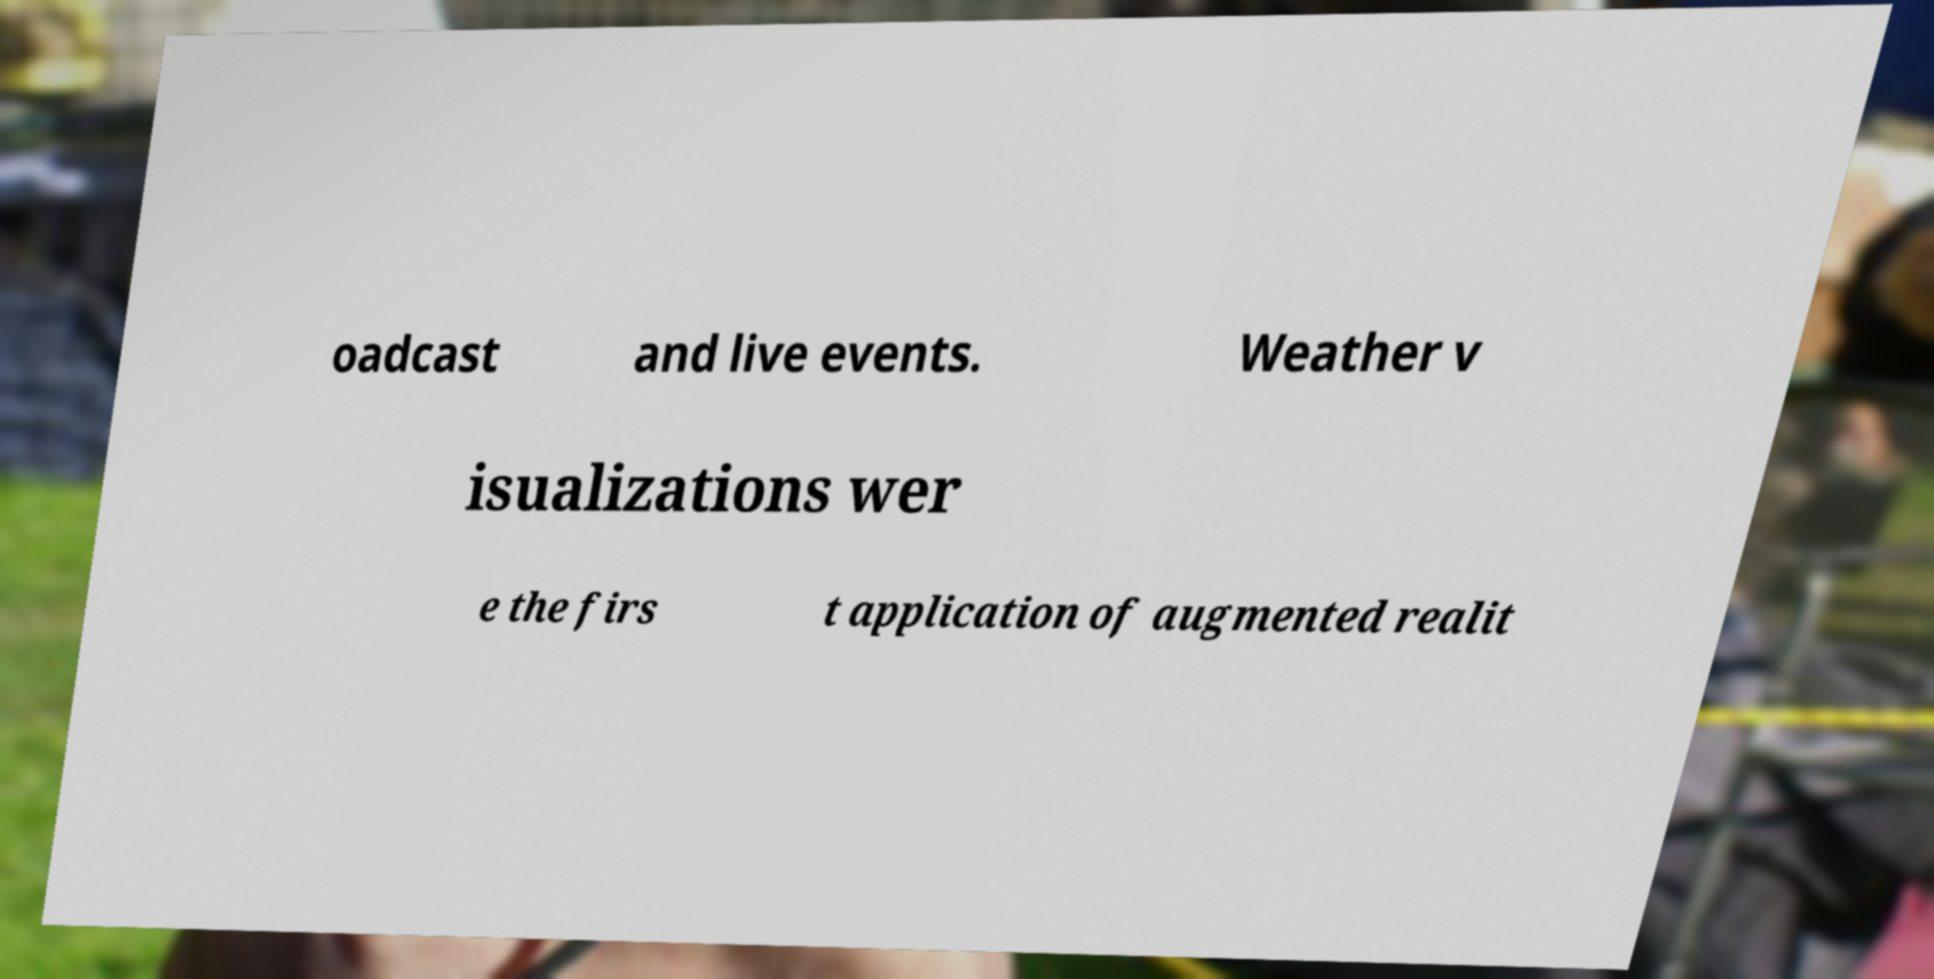I need the written content from this picture converted into text. Can you do that? oadcast and live events. Weather v isualizations wer e the firs t application of augmented realit 